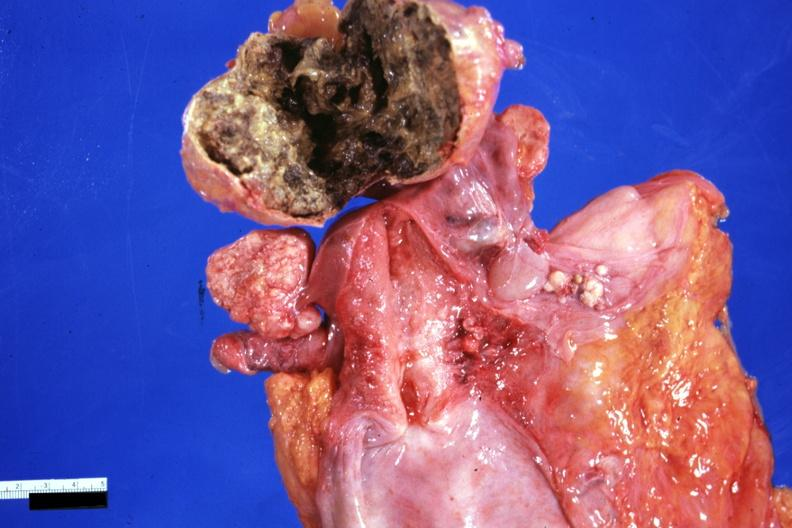does lower chest and abdomen anterior show necrotic central mass with thin fibrous capsule not all that typical 91yo?
Answer the question using a single word or phrase. No 